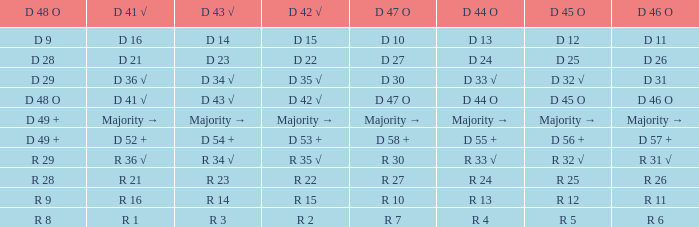Name the D 47 O with D 48 O of r 9 R 10. 